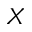<formula> <loc_0><loc_0><loc_500><loc_500>X</formula> 